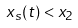<formula> <loc_0><loc_0><loc_500><loc_500>x _ { s } ( t ) < x _ { 2 }</formula> 